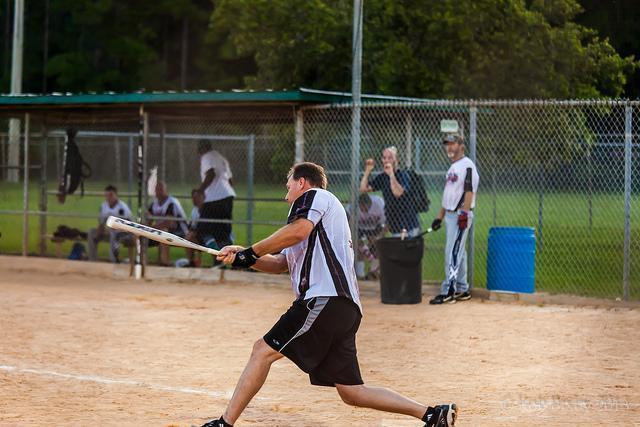How many baseball bats are in the picture?
Give a very brief answer. 1. How many people can be seen?
Give a very brief answer. 5. How many donuts are read with black face?
Give a very brief answer. 0. 